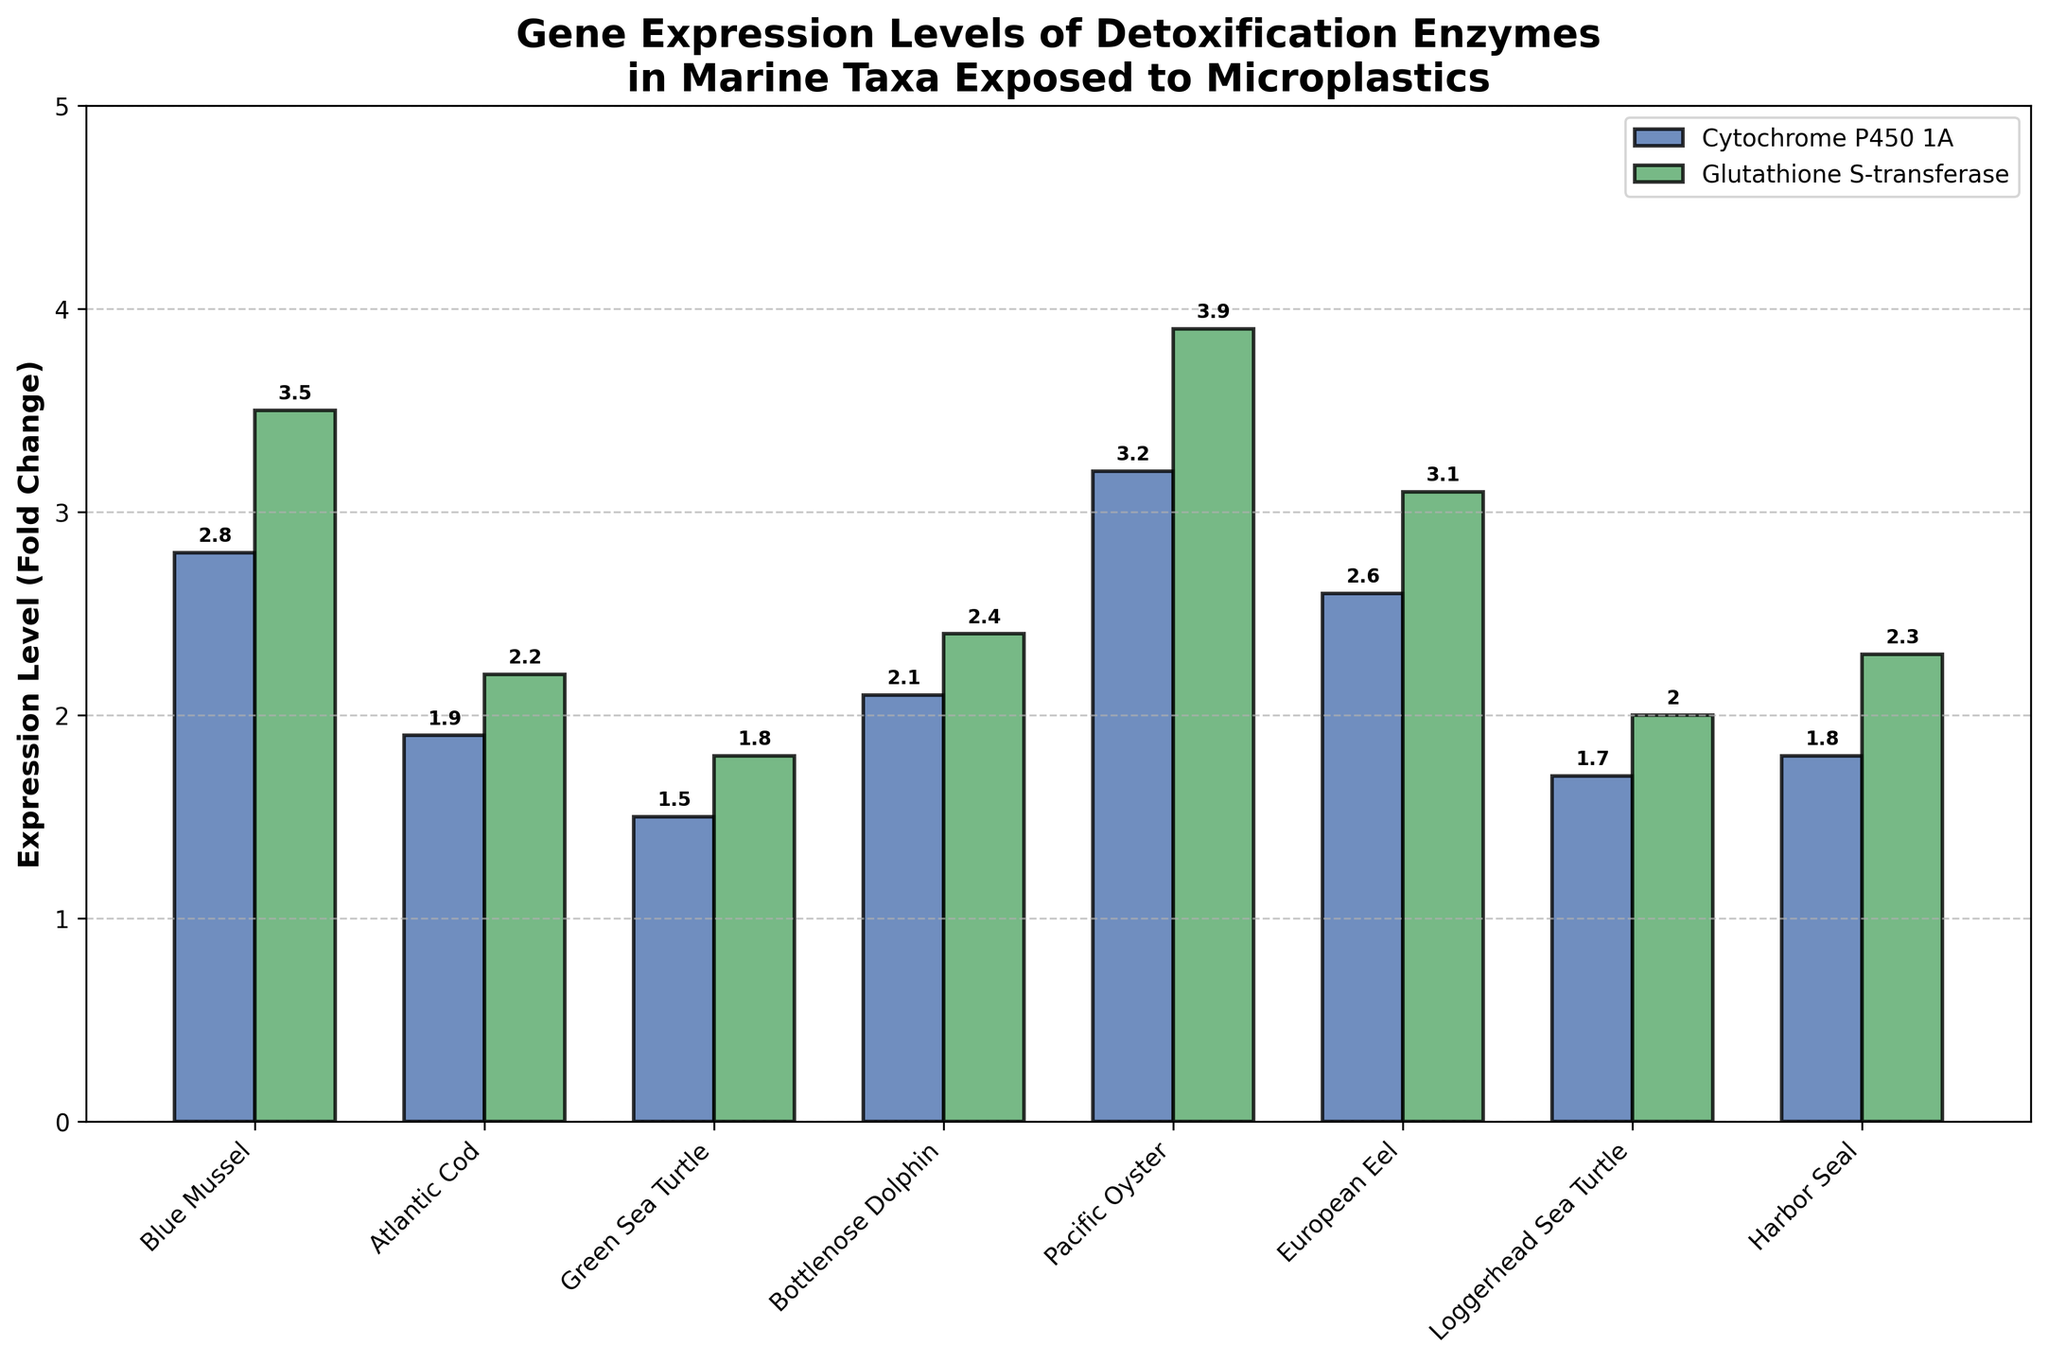What is the highest expression level of Cytochrome P450 1A and which organism does it belong to? Observe the height of the bars labeled with Cytochrome P450 1A and find the tallest one. The tallest bar for Cytochrome P450 1A is for Pacific Oyster with a value of 3.2.
Answer: Pacific Oyster, 3.2 Which organism has the lowest expression level of Glutathione S-transferase? Compare the heights of the bars labeled with Glutathione S-transferase for different organisms. The bar with the lowest height corresponds to Green Sea Turtle with a value of 1.8.
Answer: Green Sea Turtle What is the difference in the expression levels of Glutathione S-transferase between Blue Mussel and Atlantic Cod? Identify the bars for Glutathione S-transferase for Blue Mussel and Atlantic Cod and note their values: 3.5 and 2.2, respectively. The difference is calculated as 3.5 - 2.2 = 1.3.
Answer: 1.3 On average, which enzyme shows higher expression levels across all organisms? Calculate the average expression level for both enzymes by summing their values and dividing by the number of organisms. Cytochrome P450 1A: (2.8 + 1.9 + 1.5 + 2.1 + 3.2 + 2.6 + 1.7 + 1.8)/8 = 2.2. Glutathione S-transferase: (3.5 + 2.2 + 1.8 + 2.4 + 3.9 + 3.1 + 2.0 + 2.3)/8 = 2.65. Glutathione S-transferase has a higher average expression level.
Answer: Glutathione S-transferase For which organism are the expression levels of Cytochrome P450 1A and Glutathione S-transferase the closest to each other? Determine the absolute difference between the expression levels for each organism and find the smallest difference.
Answer: Loggerhead Sea Turtle (difference = 2.0 - 1.7 = 0.3) Rank the organisms based on their expression levels of Cytochrome P450 1A from highest to lowest. Compare the heights of the bars labeled with Cytochrome P450 1A and arrange them in descending order of the values: 3.2, 2.8, 2.6, 2.1, 1.9, 1.8, 1.7, 1.5.
Answer: Pacific Oyster, Blue Mussel, European Eel, Bottlenose Dolphin, Atlantic Cod, Harbor Seal, Loggerhead Sea Turtle, Green Sea Turtle Which two organisms have the highest expression levels of Glutathione S-transferase? Observe all the bars labeled with Glutathione S-transferase and identify the two tallest bars. The organisms corresponding to these bars are Pacific Oyster and Blue Mussel.
Answer: Pacific Oyster, Blue Mussel 